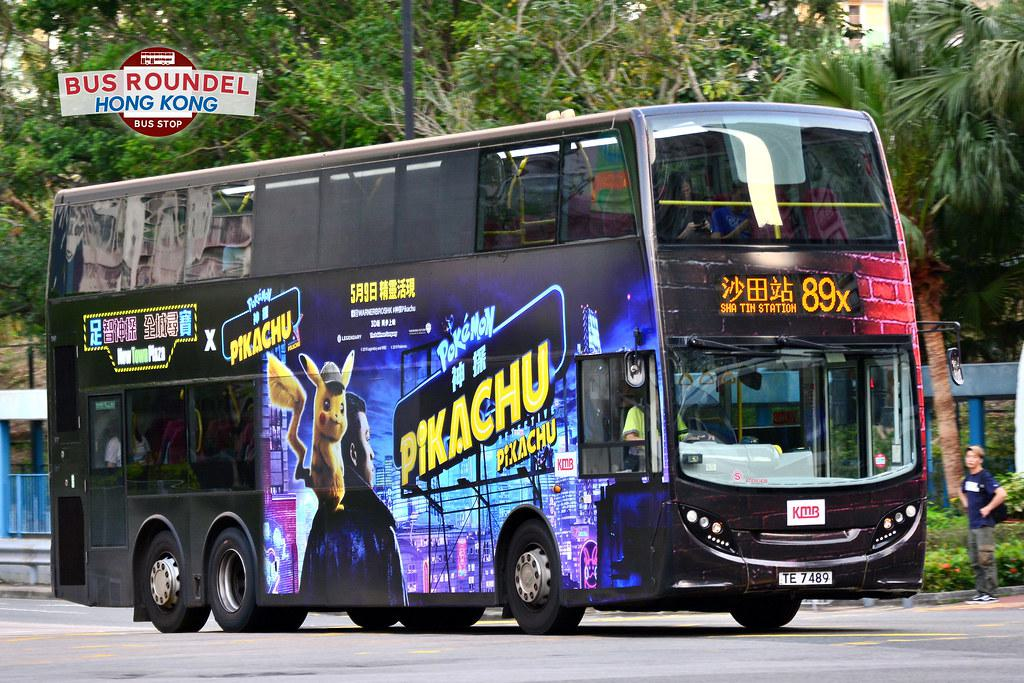Would there be a bus in the image if the bus was not in the picture? Without the bus present in the photograph, the image would likely feature the surrounding environment, such as the bus stop, roadside foliage, and any pedestrians that might be in the area. 